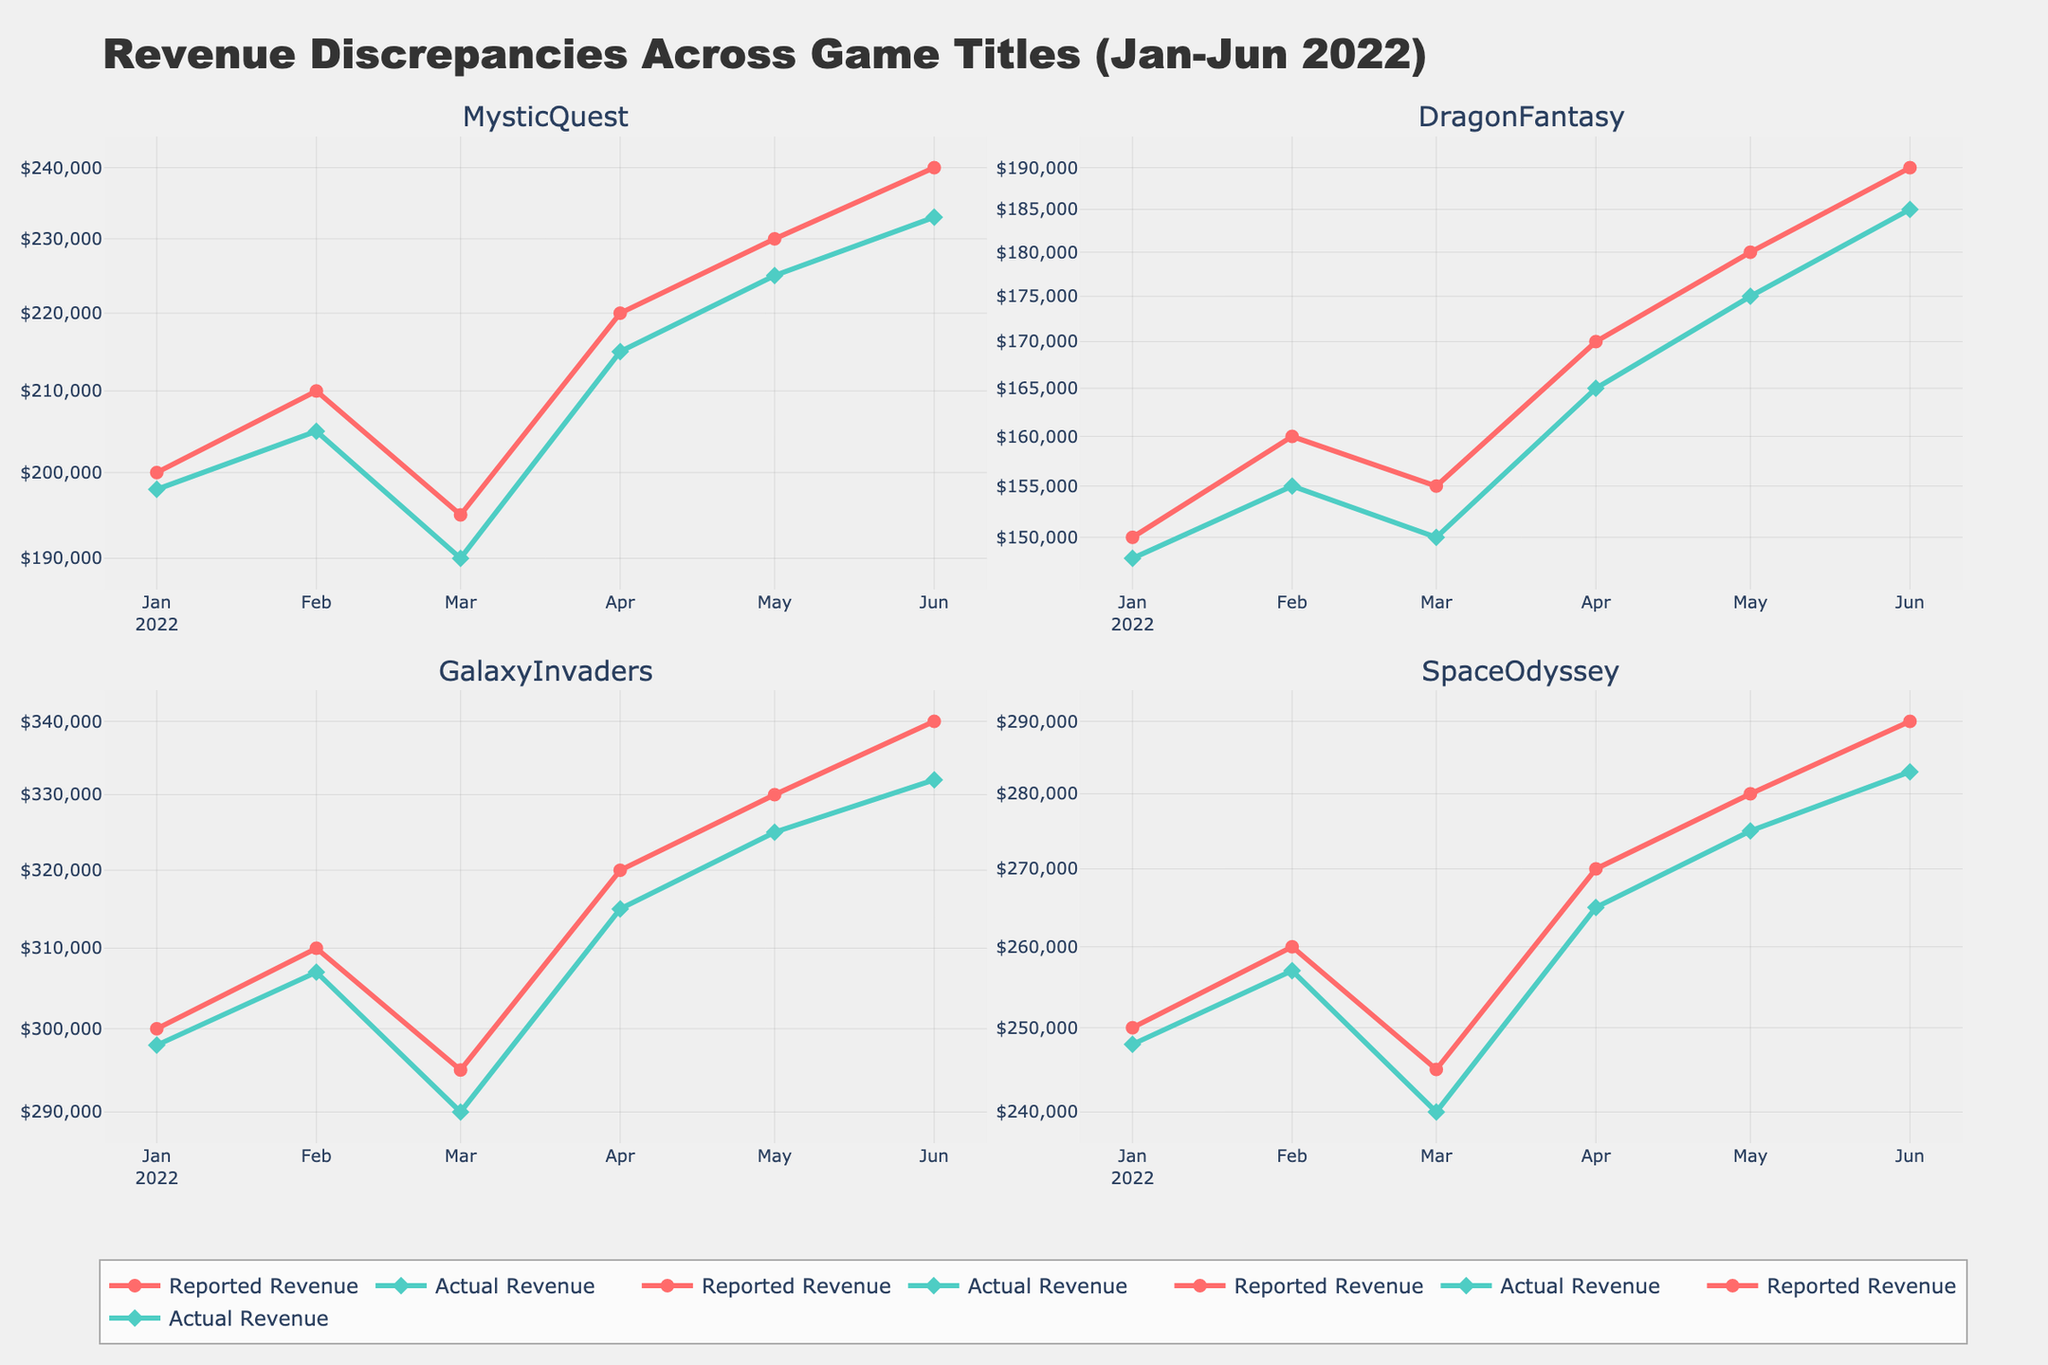How many game titles are being compared in the figure? The figure has four subplots, each titled with a game name: "MysticQuest", "DragonFantasy", "GalaxyInvaders", and "SpaceOdyssey". Thus, there are four game titles being compared.
Answer: Four Which game title shows the greatest discrepancy between Reported Revenue and Actual Revenue on any single date? Checking each subplot for the widest gap between the two lines (Reported Revenue and Actual Revenue) on any date, "GalaxyInvaders" shows the largest discrepancy in May 2022 where the Reported Revenue is $330,000 and the Actual Revenue is $325,000.
Answer: GalaxyInvaders What is the trend in the Reported Revenue for "MysticQuest" from January to June 2022? For "MysticQuest", the Reported Revenue shows an increasing trend from January to June 2022, starting at $200,000 and rising to $240,000.
Answer: Increasing Which game title shows the smallest discrepancy between Reported Revenue and Actual Revenue consistently over time? Observing visually, "SpaceOdyssey" has consistently small discrepancies between Reported Revenue and Actual Revenue compared to the other games, given the closeness of the two lines in its subplot.
Answer: SpaceOdyssey Is the difference between Reported Revenue and Actual Revenue generally increasing, decreasing, or stable for "DragonFantasy"? The difference between Reported Revenue and Actual Revenue for "DragonFantasy" appears stable over time when examining the gaps between the lines, as there isn't a noticeable trend of increasing or decreasing discrepancies.
Answer: Stable Which month has the highest Reported Revenue for "GalaxyInvaders"? Looking at the subplot for "GalaxyInvaders", the month of June has the highest Reported Revenue at $340,000.
Answer: June How does the Actual Revenue for "SpaceOdyssey" in April 2022 compare to that in May 2022? For "SpaceOdyssey", the Actual Revenue in April 2022 is $265,000, and in May 2022 it is $275,000. Therefore, the Actual Revenue in May is higher by $10,000.
Answer: Higher On which date does "MysticQuest" have the lowest Actual Revenue, and what is the value? In the subplot for "MysticQuest", the lowest Actual Revenue occurs in March 2022, with a value of $190,000.
Answer: March 2022, $190,000 Comparing all game titles, which one had the highest Actual Revenue in January 2022? By comparing the subplots, in January 2022 "GalaxyInvaders" had the highest Actual Revenue at $298,000.
Answer: GalaxyInvaders 